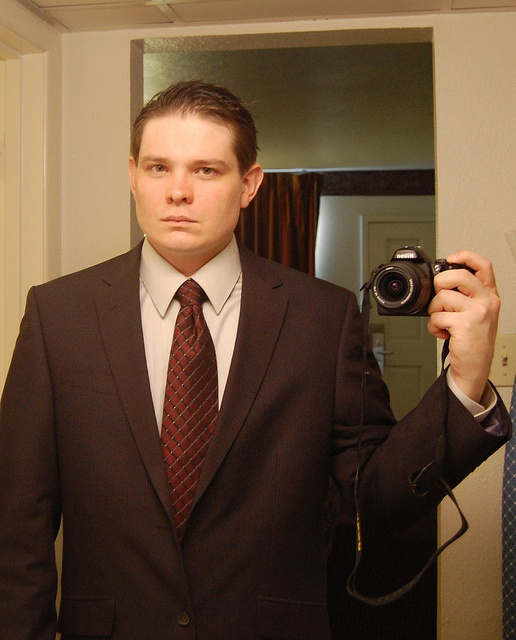Describe the objects in this image and their specific colors. I can see people in tan, black, and maroon tones and tie in tan, maroon, and brown tones in this image. 